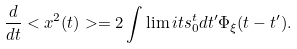<formula> <loc_0><loc_0><loc_500><loc_500>\frac { d } { d t } < x ^ { 2 } ( t ) > = 2 \int \lim i t s _ { 0 } ^ { t } d t ^ { \prime } \Phi _ { \xi } ( t - t ^ { \prime } ) .</formula> 